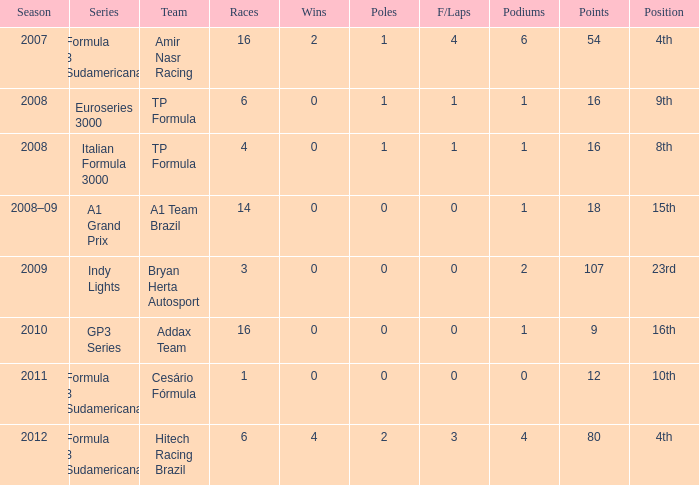Which group did he contend for in the gp3 series? Addax Team. 